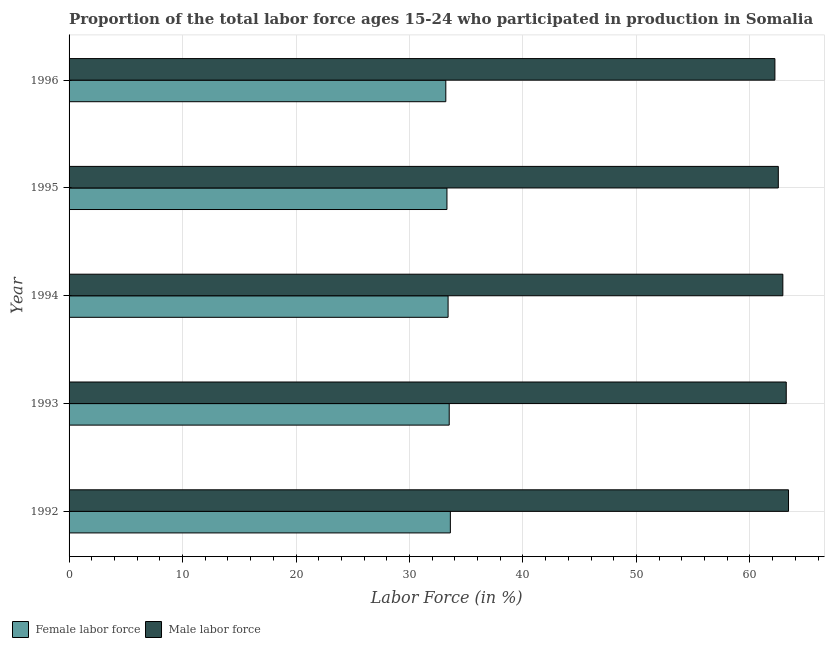How many different coloured bars are there?
Give a very brief answer. 2. Are the number of bars per tick equal to the number of legend labels?
Give a very brief answer. Yes. Are the number of bars on each tick of the Y-axis equal?
Keep it short and to the point. Yes. How many bars are there on the 2nd tick from the bottom?
Make the answer very short. 2. What is the label of the 4th group of bars from the top?
Your response must be concise. 1993. In how many cases, is the number of bars for a given year not equal to the number of legend labels?
Make the answer very short. 0. What is the percentage of female labor force in 1992?
Your response must be concise. 33.6. Across all years, what is the maximum percentage of female labor force?
Provide a short and direct response. 33.6. Across all years, what is the minimum percentage of male labour force?
Your answer should be very brief. 62.2. What is the total percentage of female labor force in the graph?
Your response must be concise. 167. What is the difference between the percentage of female labor force in 1995 and the percentage of male labour force in 1993?
Offer a terse response. -29.9. What is the average percentage of male labour force per year?
Provide a succinct answer. 62.84. In the year 1996, what is the difference between the percentage of female labor force and percentage of male labour force?
Keep it short and to the point. -29. Is the percentage of female labor force in 1992 less than that in 1994?
Provide a succinct answer. No. Is the difference between the percentage of male labour force in 1992 and 1995 greater than the difference between the percentage of female labor force in 1992 and 1995?
Your answer should be very brief. Yes. What is the difference between the highest and the lowest percentage of male labour force?
Offer a terse response. 1.2. In how many years, is the percentage of male labour force greater than the average percentage of male labour force taken over all years?
Give a very brief answer. 3. Is the sum of the percentage of male labour force in 1992 and 1995 greater than the maximum percentage of female labor force across all years?
Ensure brevity in your answer.  Yes. What does the 1st bar from the top in 1994 represents?
Provide a succinct answer. Male labor force. What does the 1st bar from the bottom in 1995 represents?
Your answer should be compact. Female labor force. Are all the bars in the graph horizontal?
Offer a very short reply. Yes. Where does the legend appear in the graph?
Provide a short and direct response. Bottom left. What is the title of the graph?
Provide a succinct answer. Proportion of the total labor force ages 15-24 who participated in production in Somalia. Does "Mobile cellular" appear as one of the legend labels in the graph?
Provide a succinct answer. No. What is the label or title of the Y-axis?
Offer a terse response. Year. What is the Labor Force (in %) in Female labor force in 1992?
Provide a short and direct response. 33.6. What is the Labor Force (in %) in Male labor force in 1992?
Offer a terse response. 63.4. What is the Labor Force (in %) in Female labor force in 1993?
Provide a short and direct response. 33.5. What is the Labor Force (in %) in Male labor force in 1993?
Your response must be concise. 63.2. What is the Labor Force (in %) of Female labor force in 1994?
Your response must be concise. 33.4. What is the Labor Force (in %) in Male labor force in 1994?
Provide a short and direct response. 62.9. What is the Labor Force (in %) of Female labor force in 1995?
Give a very brief answer. 33.3. What is the Labor Force (in %) of Male labor force in 1995?
Provide a succinct answer. 62.5. What is the Labor Force (in %) of Female labor force in 1996?
Your answer should be very brief. 33.2. What is the Labor Force (in %) of Male labor force in 1996?
Offer a terse response. 62.2. Across all years, what is the maximum Labor Force (in %) in Female labor force?
Your response must be concise. 33.6. Across all years, what is the maximum Labor Force (in %) of Male labor force?
Your answer should be compact. 63.4. Across all years, what is the minimum Labor Force (in %) in Female labor force?
Make the answer very short. 33.2. Across all years, what is the minimum Labor Force (in %) in Male labor force?
Ensure brevity in your answer.  62.2. What is the total Labor Force (in %) of Female labor force in the graph?
Your answer should be compact. 167. What is the total Labor Force (in %) of Male labor force in the graph?
Your response must be concise. 314.2. What is the difference between the Labor Force (in %) in Male labor force in 1992 and that in 1994?
Offer a terse response. 0.5. What is the difference between the Labor Force (in %) in Female labor force in 1992 and that in 1995?
Offer a terse response. 0.3. What is the difference between the Labor Force (in %) of Male labor force in 1992 and that in 1995?
Offer a terse response. 0.9. What is the difference between the Labor Force (in %) in Female labor force in 1992 and that in 1996?
Provide a short and direct response. 0.4. What is the difference between the Labor Force (in %) of Male labor force in 1992 and that in 1996?
Give a very brief answer. 1.2. What is the difference between the Labor Force (in %) of Female labor force in 1993 and that in 1994?
Provide a short and direct response. 0.1. What is the difference between the Labor Force (in %) in Male labor force in 1993 and that in 1994?
Offer a terse response. 0.3. What is the difference between the Labor Force (in %) in Female labor force in 1993 and that in 1995?
Offer a very short reply. 0.2. What is the difference between the Labor Force (in %) of Male labor force in 1993 and that in 1996?
Provide a short and direct response. 1. What is the difference between the Labor Force (in %) in Male labor force in 1994 and that in 1995?
Offer a very short reply. 0.4. What is the difference between the Labor Force (in %) in Female labor force in 1994 and that in 1996?
Your answer should be compact. 0.2. What is the difference between the Labor Force (in %) in Male labor force in 1994 and that in 1996?
Make the answer very short. 0.7. What is the difference between the Labor Force (in %) in Female labor force in 1995 and that in 1996?
Your answer should be very brief. 0.1. What is the difference between the Labor Force (in %) in Female labor force in 1992 and the Labor Force (in %) in Male labor force in 1993?
Keep it short and to the point. -29.6. What is the difference between the Labor Force (in %) of Female labor force in 1992 and the Labor Force (in %) of Male labor force in 1994?
Keep it short and to the point. -29.3. What is the difference between the Labor Force (in %) in Female labor force in 1992 and the Labor Force (in %) in Male labor force in 1995?
Your answer should be compact. -28.9. What is the difference between the Labor Force (in %) in Female labor force in 1992 and the Labor Force (in %) in Male labor force in 1996?
Your response must be concise. -28.6. What is the difference between the Labor Force (in %) of Female labor force in 1993 and the Labor Force (in %) of Male labor force in 1994?
Provide a succinct answer. -29.4. What is the difference between the Labor Force (in %) of Female labor force in 1993 and the Labor Force (in %) of Male labor force in 1996?
Ensure brevity in your answer.  -28.7. What is the difference between the Labor Force (in %) of Female labor force in 1994 and the Labor Force (in %) of Male labor force in 1995?
Provide a succinct answer. -29.1. What is the difference between the Labor Force (in %) of Female labor force in 1994 and the Labor Force (in %) of Male labor force in 1996?
Provide a succinct answer. -28.8. What is the difference between the Labor Force (in %) of Female labor force in 1995 and the Labor Force (in %) of Male labor force in 1996?
Offer a very short reply. -28.9. What is the average Labor Force (in %) of Female labor force per year?
Provide a succinct answer. 33.4. What is the average Labor Force (in %) of Male labor force per year?
Your answer should be very brief. 62.84. In the year 1992, what is the difference between the Labor Force (in %) of Female labor force and Labor Force (in %) of Male labor force?
Keep it short and to the point. -29.8. In the year 1993, what is the difference between the Labor Force (in %) of Female labor force and Labor Force (in %) of Male labor force?
Ensure brevity in your answer.  -29.7. In the year 1994, what is the difference between the Labor Force (in %) in Female labor force and Labor Force (in %) in Male labor force?
Ensure brevity in your answer.  -29.5. In the year 1995, what is the difference between the Labor Force (in %) in Female labor force and Labor Force (in %) in Male labor force?
Keep it short and to the point. -29.2. What is the ratio of the Labor Force (in %) of Female labor force in 1992 to that in 1994?
Offer a very short reply. 1.01. What is the ratio of the Labor Force (in %) in Male labor force in 1992 to that in 1994?
Offer a terse response. 1.01. What is the ratio of the Labor Force (in %) in Female labor force in 1992 to that in 1995?
Offer a terse response. 1.01. What is the ratio of the Labor Force (in %) in Male labor force in 1992 to that in 1995?
Provide a succinct answer. 1.01. What is the ratio of the Labor Force (in %) in Male labor force in 1992 to that in 1996?
Your answer should be compact. 1.02. What is the ratio of the Labor Force (in %) in Male labor force in 1993 to that in 1994?
Ensure brevity in your answer.  1. What is the ratio of the Labor Force (in %) of Female labor force in 1993 to that in 1995?
Offer a terse response. 1.01. What is the ratio of the Labor Force (in %) in Male labor force in 1993 to that in 1995?
Your answer should be very brief. 1.01. What is the ratio of the Labor Force (in %) in Male labor force in 1993 to that in 1996?
Offer a terse response. 1.02. What is the ratio of the Labor Force (in %) of Male labor force in 1994 to that in 1995?
Offer a very short reply. 1.01. What is the ratio of the Labor Force (in %) in Female labor force in 1994 to that in 1996?
Provide a succinct answer. 1.01. What is the ratio of the Labor Force (in %) in Male labor force in 1994 to that in 1996?
Keep it short and to the point. 1.01. What is the difference between the highest and the second highest Labor Force (in %) of Female labor force?
Give a very brief answer. 0.1. What is the difference between the highest and the second highest Labor Force (in %) of Male labor force?
Offer a terse response. 0.2. 